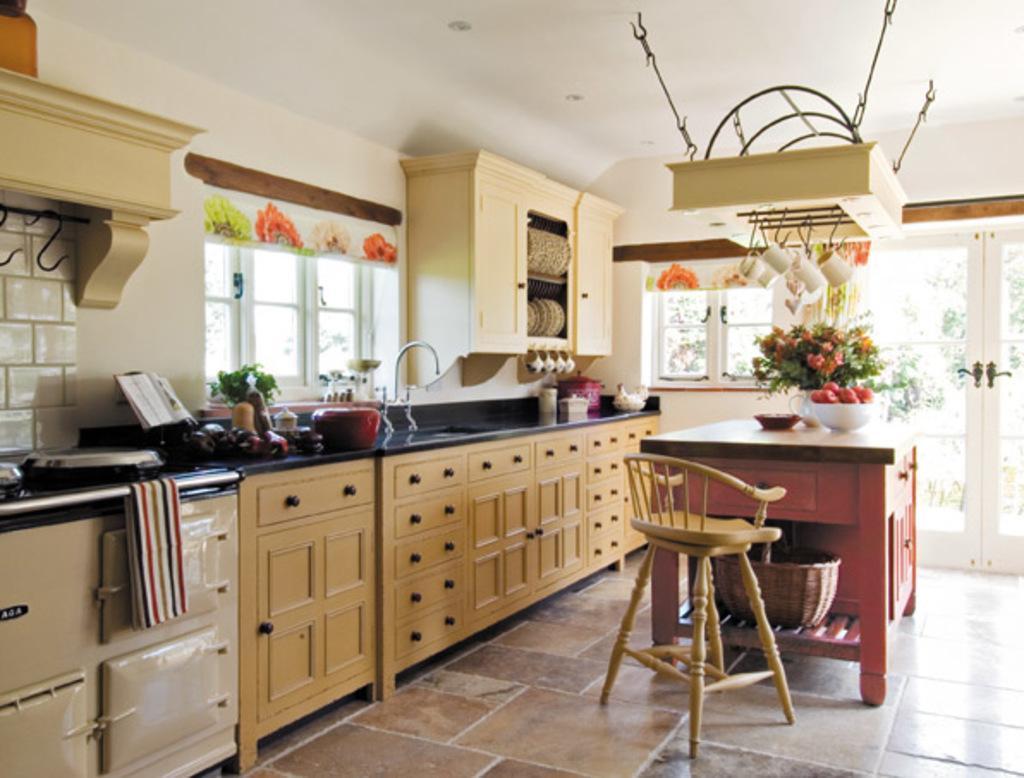Describe this image in one or two sentences. Picture inside of a kitchen. This is a furniture, above this furniture there is a container, sink with taps, box and things. This is cupboard, in this cupboard there are plates and cups. On this table there is a bowl, flowers, fruits and plate. Under the table there is a basket. This is chair. This is door with handle. 